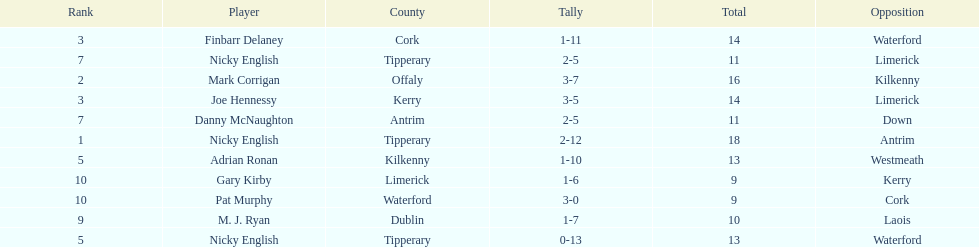How many times was waterford the opposition? 2. 